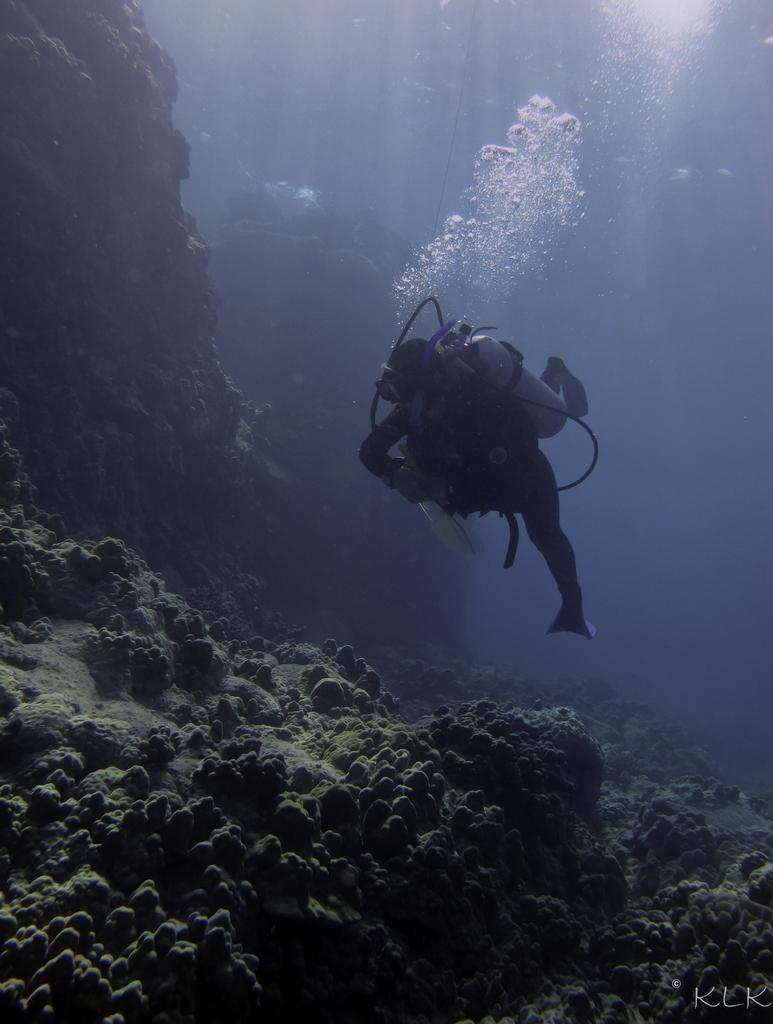What are the people in the image doing? There are deep sea divers in the water. What can be seen coming from the divers? The divers are leaving bubbles. What type of environment is the image set in? The divers are in the water, which suggests an underwater environment. What can be seen under the divers? There are water stones visible under the divers. What type of cracker is being used to shape the divers' bubbles in the image? There is no cracker present in the image, and the divers' bubbles are not shaped by any external object. 